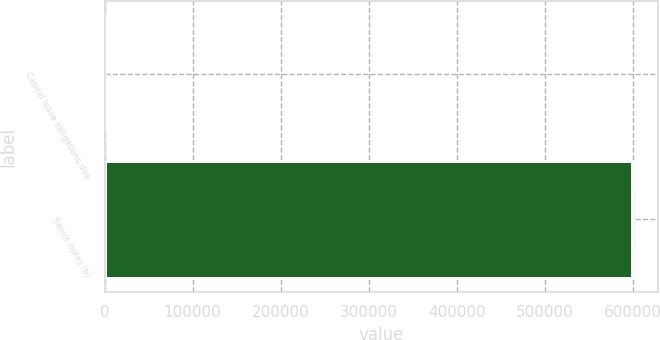Convert chart. <chart><loc_0><loc_0><loc_500><loc_500><bar_chart><fcel>Capital lease obligations due<fcel>Senior notes (b)<nl><fcel>757<fcel>598988<nl></chart> 